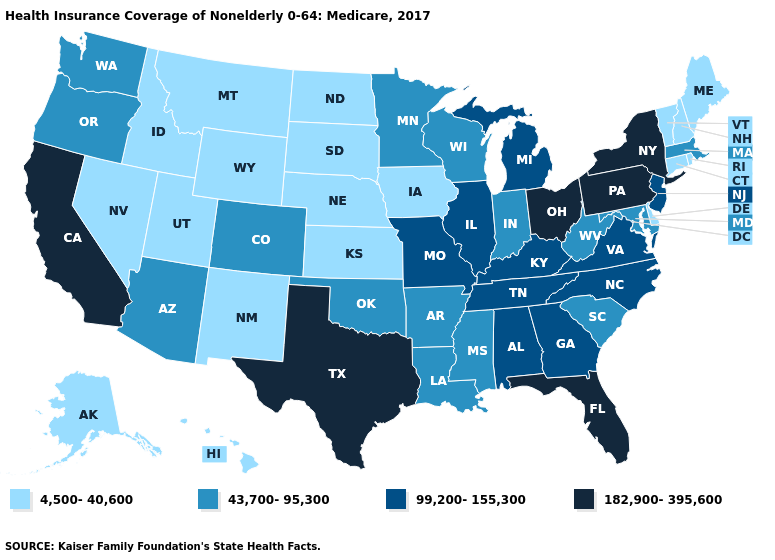What is the value of Kansas?
Concise answer only. 4,500-40,600. What is the value of Wisconsin?
Concise answer only. 43,700-95,300. Name the states that have a value in the range 43,700-95,300?
Answer briefly. Arizona, Arkansas, Colorado, Indiana, Louisiana, Maryland, Massachusetts, Minnesota, Mississippi, Oklahoma, Oregon, South Carolina, Washington, West Virginia, Wisconsin. Does Colorado have the highest value in the West?
Answer briefly. No. Does Missouri have a lower value than Nevada?
Quick response, please. No. Name the states that have a value in the range 4,500-40,600?
Quick response, please. Alaska, Connecticut, Delaware, Hawaii, Idaho, Iowa, Kansas, Maine, Montana, Nebraska, Nevada, New Hampshire, New Mexico, North Dakota, Rhode Island, South Dakota, Utah, Vermont, Wyoming. Does the map have missing data?
Be succinct. No. Does Pennsylvania have the highest value in the USA?
Keep it brief. Yes. Name the states that have a value in the range 182,900-395,600?
Be succinct. California, Florida, New York, Ohio, Pennsylvania, Texas. Which states have the highest value in the USA?
Short answer required. California, Florida, New York, Ohio, Pennsylvania, Texas. What is the value of Illinois?
Answer briefly. 99,200-155,300. Does the first symbol in the legend represent the smallest category?
Write a very short answer. Yes. Does the first symbol in the legend represent the smallest category?
Write a very short answer. Yes. Does California have the highest value in the West?
Short answer required. Yes. What is the value of New Hampshire?
Concise answer only. 4,500-40,600. 